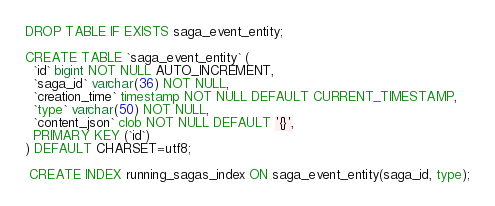Convert code to text. <code><loc_0><loc_0><loc_500><loc_500><_SQL_>DROP TABLE IF EXISTS saga_event_entity;

CREATE TABLE `saga_event_entity` (
  `id` bigint NOT NULL AUTO_INCREMENT,
  `saga_id` varchar(36) NOT NULL,
  `creation_time` timestamp NOT NULL DEFAULT CURRENT_TIMESTAMP,
  `type` varchar(50) NOT NULL,
  `content_json` clob NOT NULL DEFAULT '{}',
  PRIMARY KEY (`id`)
) DEFAULT CHARSET=utf8;

 CREATE INDEX running_sagas_index ON saga_event_entity(saga_id, type);
</code> 